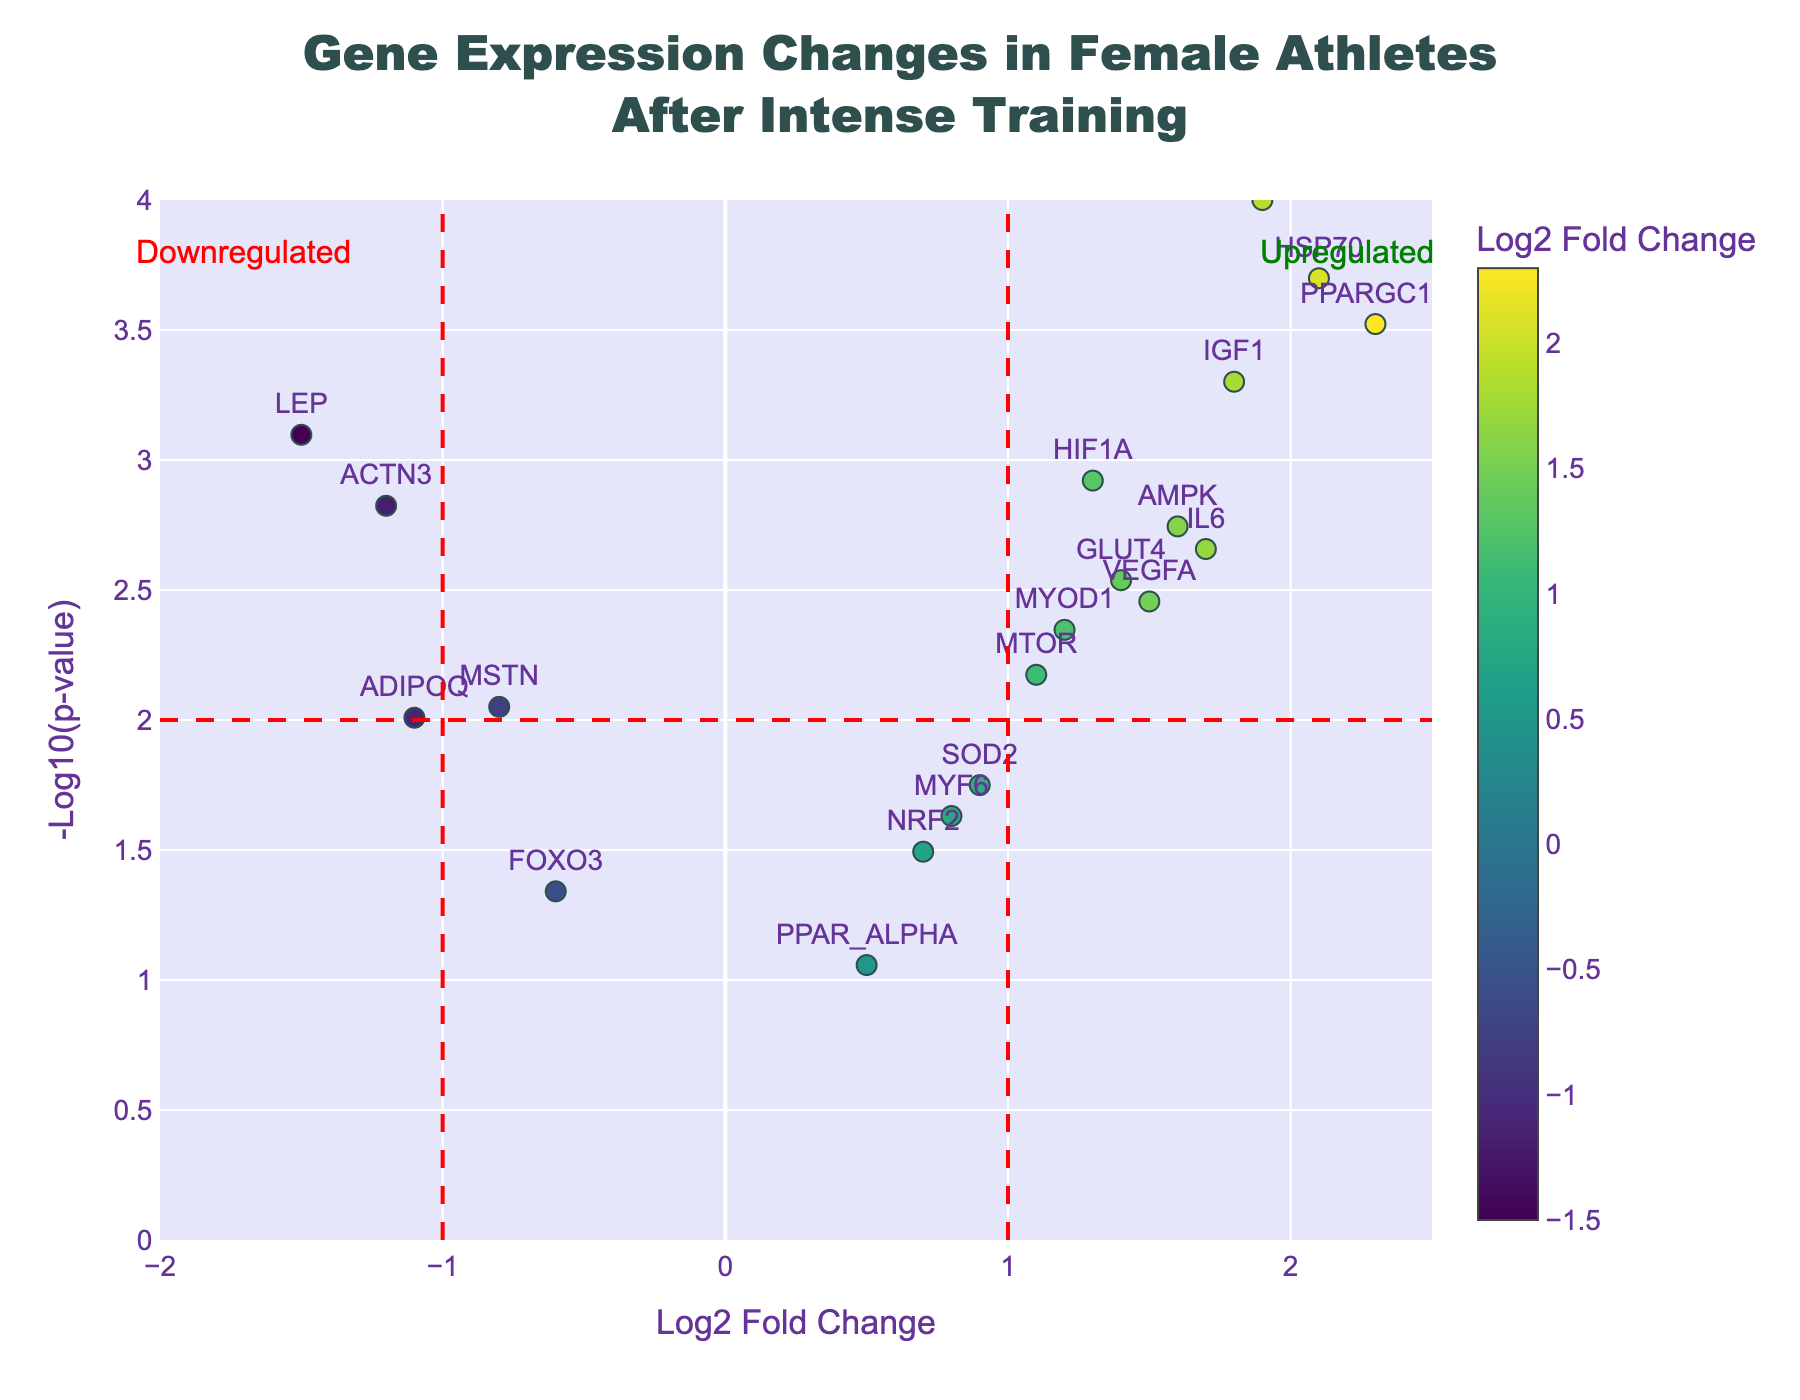What's the title of the figure? The title is displayed prominently at the top in a larger font size. By reading it, you can see that it states "Gene Expression Changes in Female Athletes After Intense Training".
Answer: Gene Expression Changes in Female Athletes After Intense Training What information is shown on the x-axis? The x-axis title, located below the x-axis, reads "Log2 Fold Change", indicating that it displays the Log2 fold change of gene expression.
Answer: Log2 Fold Change Which gene has the highest p-value? To determine this, you'd look at the y-values on the plot and find the gene positioned lowest on the y-axis, which correspond to the highest p-value. The gene labeled "PPAR_ALPHA" is the lowest.
Answer: PPAR_ALPHA Which gene shows the highest upregulation? The highest upregulation would be the gene with the greatest positive Log2 fold change. On the plot, "PPARGC1A" has the highest positive x-value.
Answer: PPARGC1A Which genes are significantly upregulated? Significant upregulation can be determined by looking for genes with a Log2 fold change greater than 1 and a -log10(p-value) above 2. From the plot, these genes are "PPARGC1A", "CKM", "IGF1", "HSP70", and "AMPK".
Answer: PPARGC1A, CKM, IGF1, HSP70, AMPK What is the color variance of the markers based on? The legend indicates that the color variance of the markers depends on the Log2 fold change values, where different colors represent different values.
Answer: Log2 fold change values How many genes have a p-value less than 0.01? A p-value < 0.01 corresponds to a -log10(p-value) higher than 2. Counting the points above the horizontal red dashed line, there are eleven such genes.
Answer: 11 Which gene is closest to the threshold for significant downregulation? Significant downregulation is indicated by a Log2 fold change less than -1. The gene closest to this threshold but still passing it is "LEP".
Answer: LEP How does VEGFA’s regulatory change compare to IL6's? Comparison involves noting the fold changes and p-values. "VEGFA" has a Log2 fold change of 1.5 and a p-value of 0.0035, while "IL6" has a Log2 fold change of 1.7 and a p-value of 0.0022. IL6 is both more upregulated and more significant than VEGFA.
Answer: IL6 is more upregulated and more significant than VEGFA 